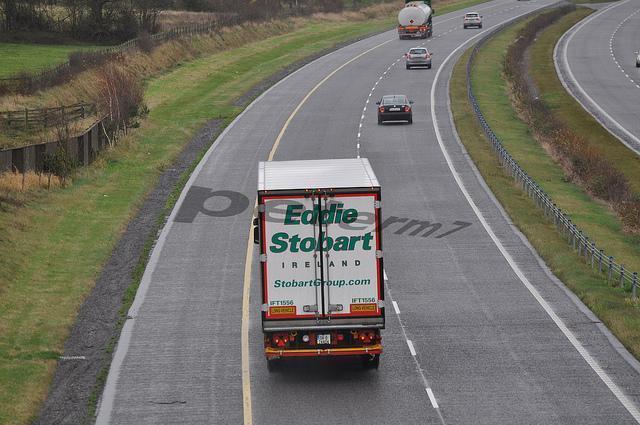How many vehicles are not trucks?
Give a very brief answer. 3. 